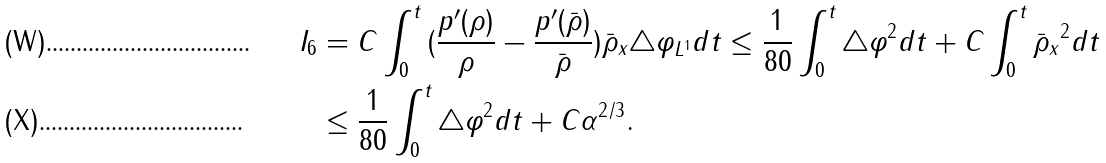<formula> <loc_0><loc_0><loc_500><loc_500>I _ { 6 } & = C \int _ { 0 } ^ { t } \| ( \frac { p ^ { \prime } ( \rho ) } { \rho } - \frac { p ^ { \prime } ( \bar { \rho } ) } { \bar { \rho } } ) \bar { \rho } _ { x } \triangle \varphi \| _ { L ^ { 1 } } d t \leq \frac { 1 } { 8 0 } \int _ { 0 } ^ { t } \| \triangle \varphi \| ^ { 2 } d t + C \int _ { 0 } ^ { t } \| \bar { \rho } _ { x } \| ^ { 2 } d t \\ & \leq \frac { 1 } { 8 0 } \int _ { 0 } ^ { t } \| \triangle \varphi \| ^ { 2 } d t + C \alpha ^ { 2 / 3 } .</formula> 